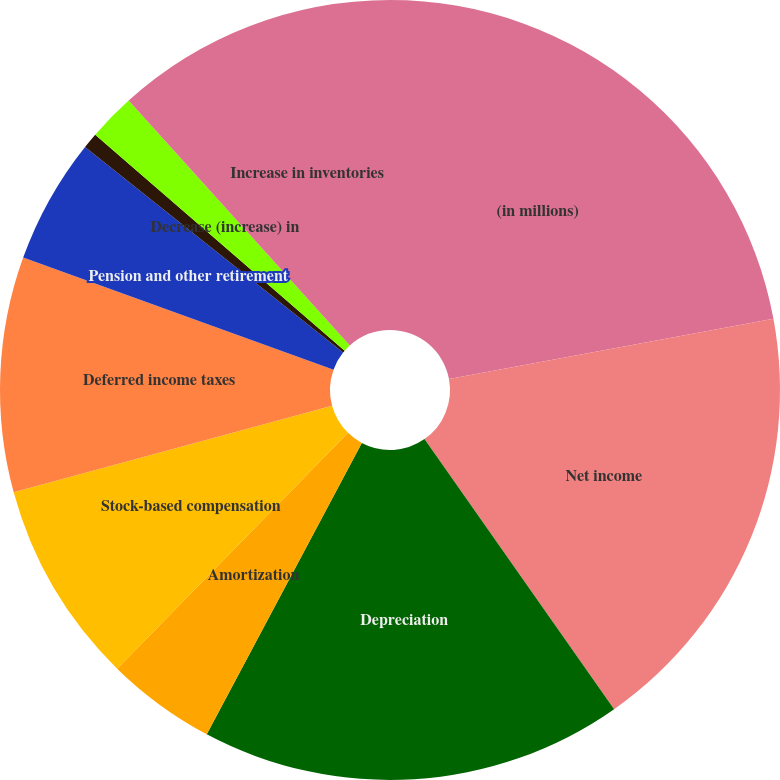Convert chart to OTSL. <chart><loc_0><loc_0><loc_500><loc_500><pie_chart><fcel>(in millions)<fcel>Net income<fcel>Depreciation<fcel>Amortization<fcel>Stock-based compensation<fcel>Deferred income taxes<fcel>Pension and other retirement<fcel>Equity in undistributed<fcel>Decrease (increase) in<fcel>Increase in inventories<nl><fcel>22.08%<fcel>18.18%<fcel>17.53%<fcel>4.55%<fcel>8.44%<fcel>9.74%<fcel>5.2%<fcel>0.65%<fcel>1.95%<fcel>11.69%<nl></chart> 